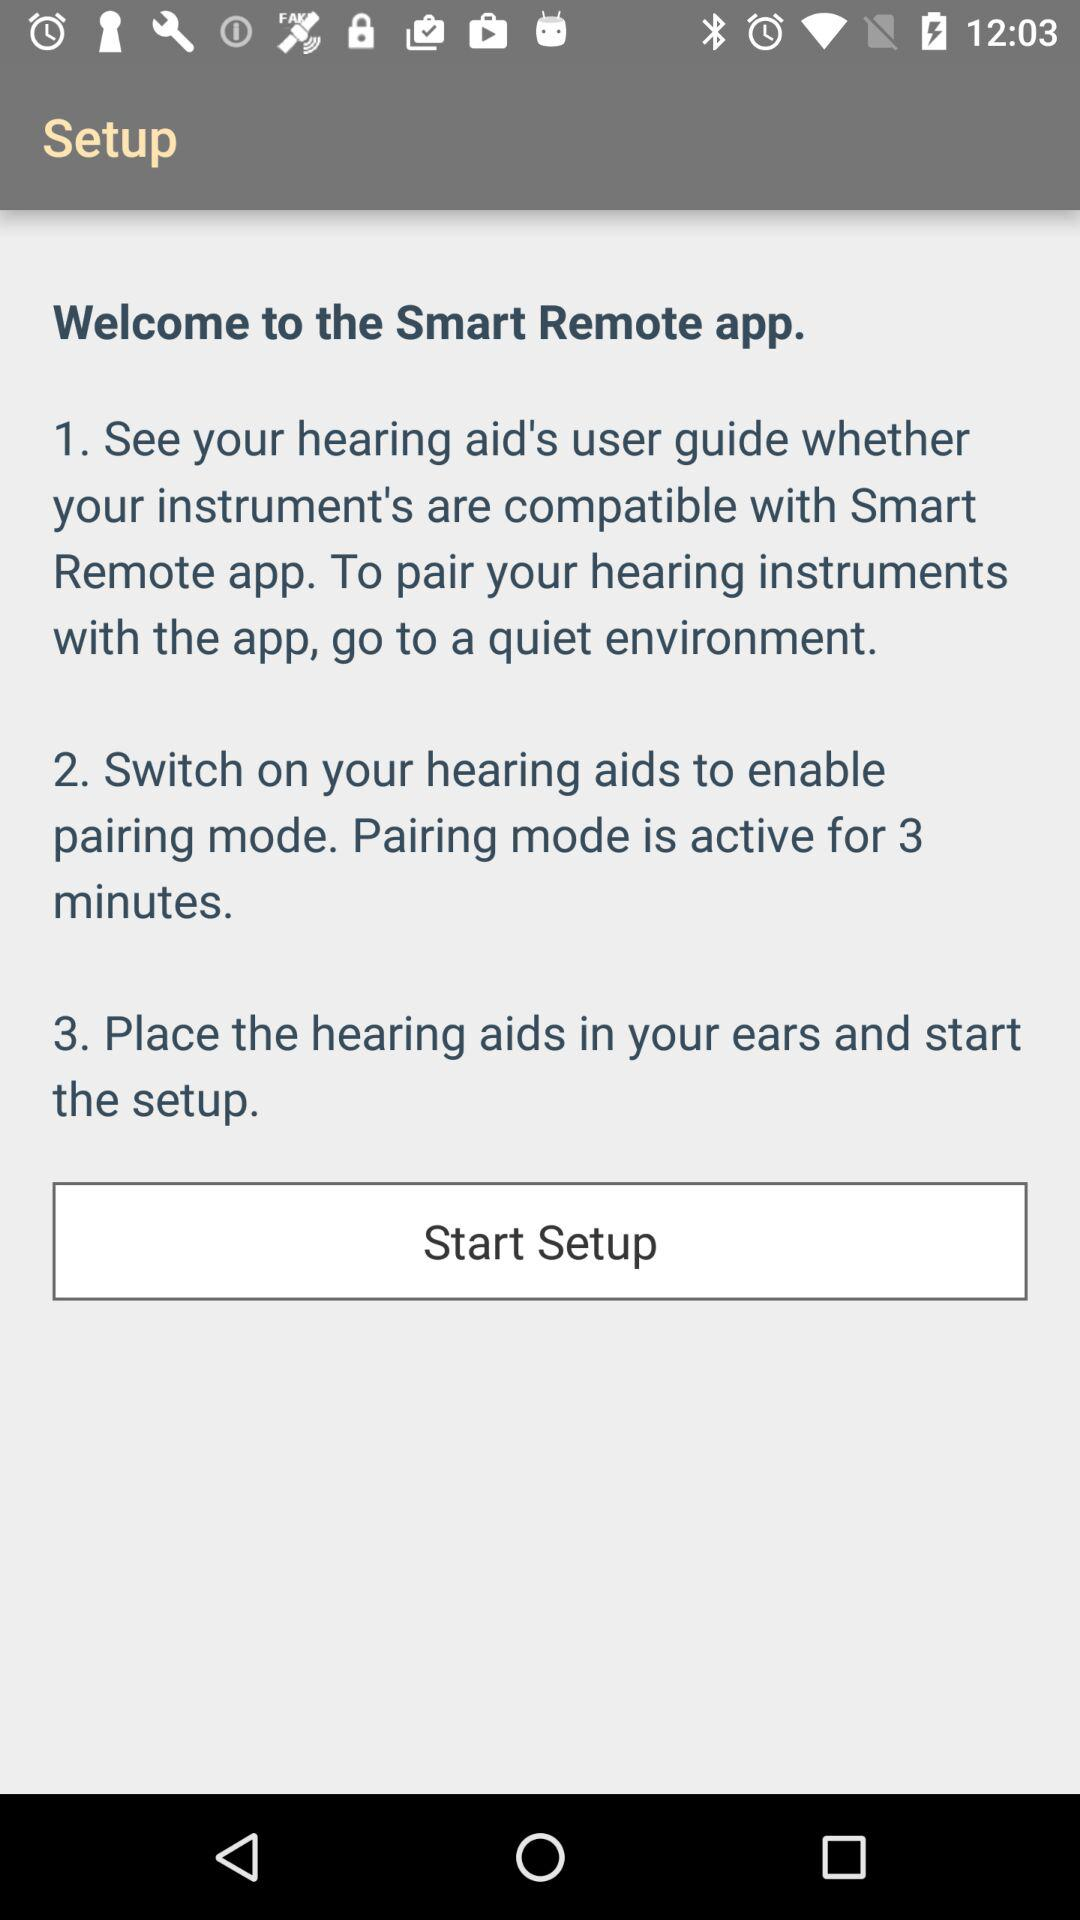How many steps are there in the setup process?
Answer the question using a single word or phrase. 3 